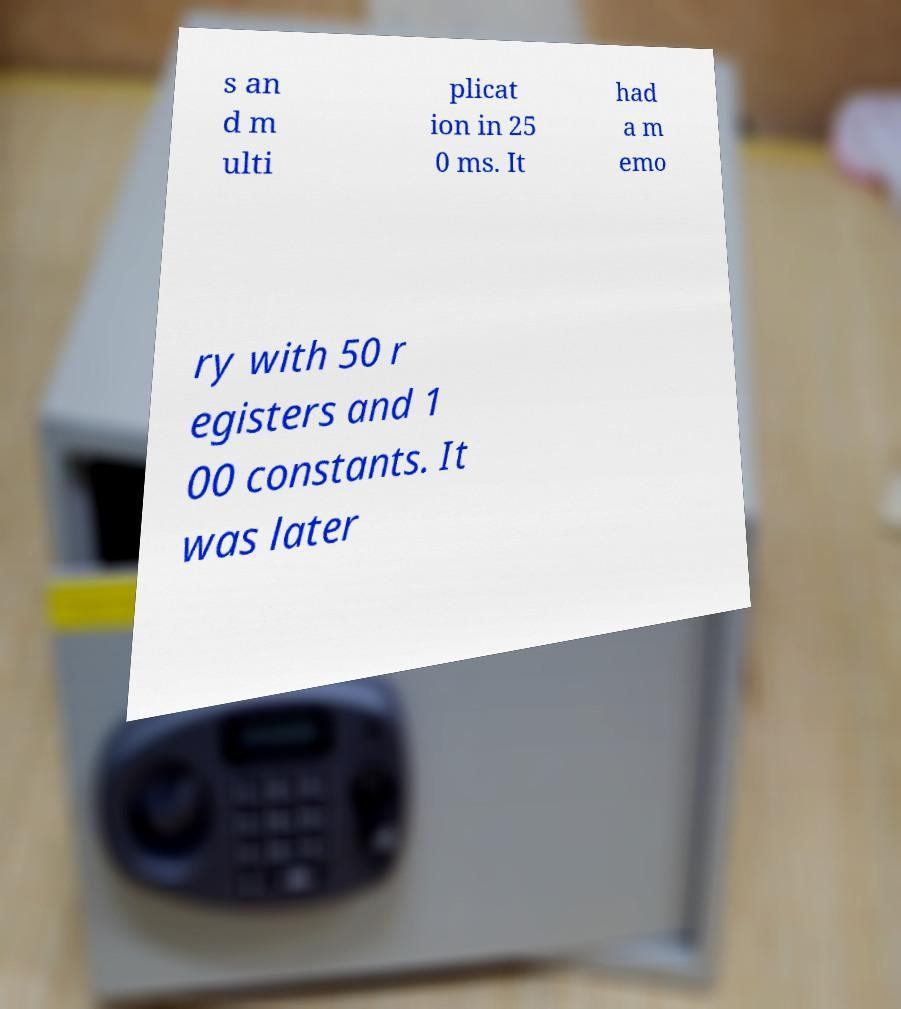Can you read and provide the text displayed in the image?This photo seems to have some interesting text. Can you extract and type it out for me? s an d m ulti plicat ion in 25 0 ms. It had a m emo ry with 50 r egisters and 1 00 constants. It was later 